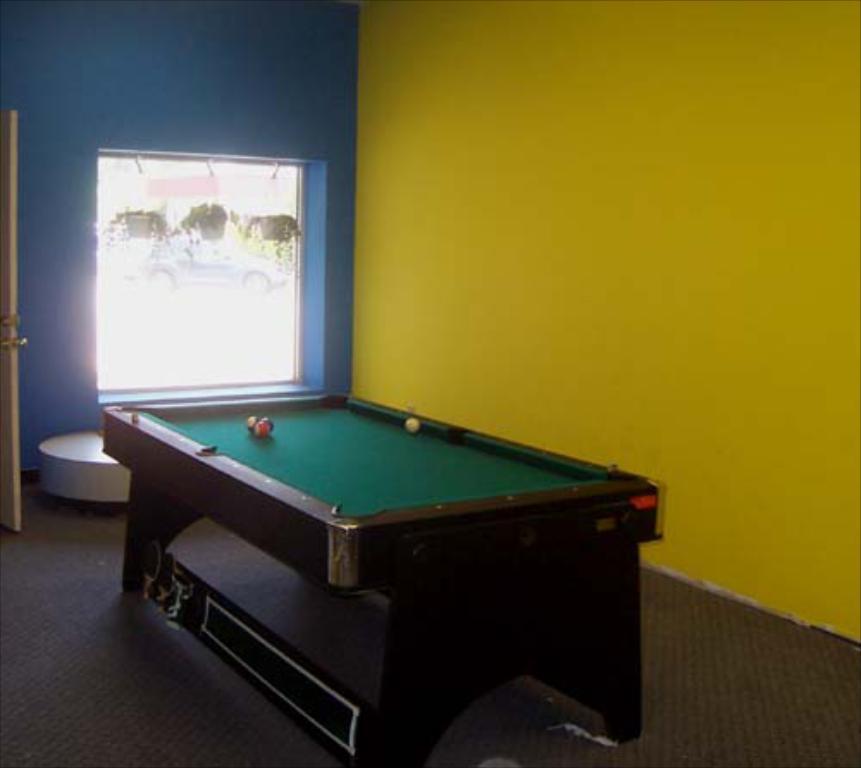Can you describe this image briefly? Inside is a room, there is a snooker table beside the table there is a yellow color wall, beside that yellow color wall there is also a blue color wall, which has a window , to the left side there is a door. 